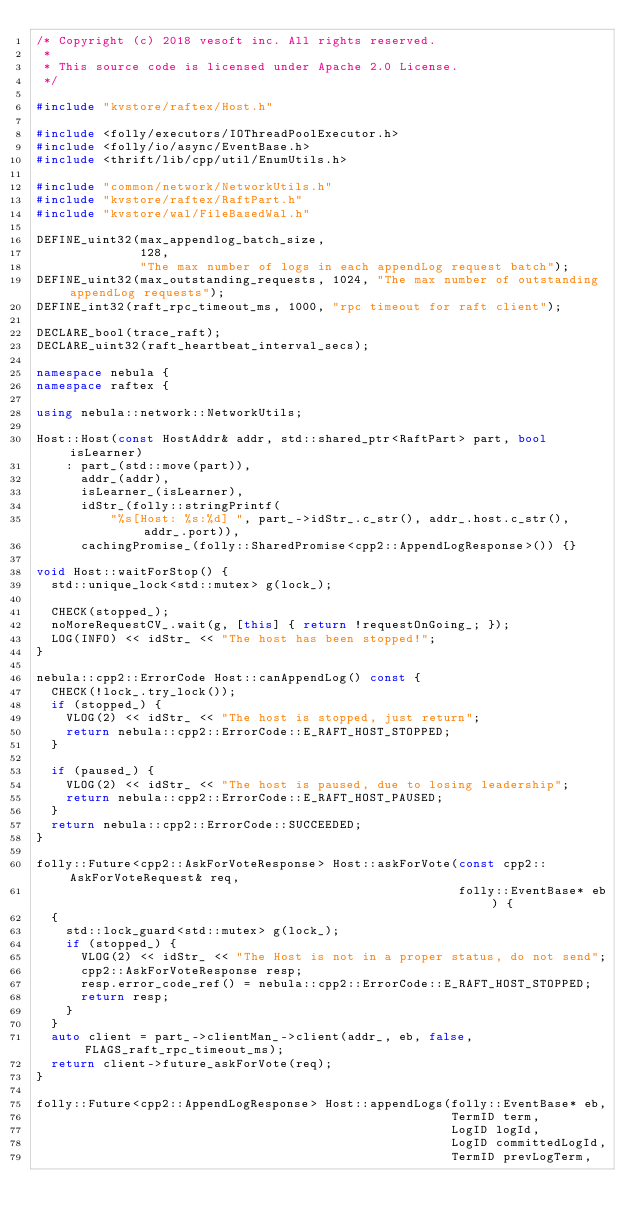Convert code to text. <code><loc_0><loc_0><loc_500><loc_500><_C++_>/* Copyright (c) 2018 vesoft inc. All rights reserved.
 *
 * This source code is licensed under Apache 2.0 License.
 */

#include "kvstore/raftex/Host.h"

#include <folly/executors/IOThreadPoolExecutor.h>
#include <folly/io/async/EventBase.h>
#include <thrift/lib/cpp/util/EnumUtils.h>

#include "common/network/NetworkUtils.h"
#include "kvstore/raftex/RaftPart.h"
#include "kvstore/wal/FileBasedWal.h"

DEFINE_uint32(max_appendlog_batch_size,
              128,
              "The max number of logs in each appendLog request batch");
DEFINE_uint32(max_outstanding_requests, 1024, "The max number of outstanding appendLog requests");
DEFINE_int32(raft_rpc_timeout_ms, 1000, "rpc timeout for raft client");

DECLARE_bool(trace_raft);
DECLARE_uint32(raft_heartbeat_interval_secs);

namespace nebula {
namespace raftex {

using nebula::network::NetworkUtils;

Host::Host(const HostAddr& addr, std::shared_ptr<RaftPart> part, bool isLearner)
    : part_(std::move(part)),
      addr_(addr),
      isLearner_(isLearner),
      idStr_(folly::stringPrintf(
          "%s[Host: %s:%d] ", part_->idStr_.c_str(), addr_.host.c_str(), addr_.port)),
      cachingPromise_(folly::SharedPromise<cpp2::AppendLogResponse>()) {}

void Host::waitForStop() {
  std::unique_lock<std::mutex> g(lock_);

  CHECK(stopped_);
  noMoreRequestCV_.wait(g, [this] { return !requestOnGoing_; });
  LOG(INFO) << idStr_ << "The host has been stopped!";
}

nebula::cpp2::ErrorCode Host::canAppendLog() const {
  CHECK(!lock_.try_lock());
  if (stopped_) {
    VLOG(2) << idStr_ << "The host is stopped, just return";
    return nebula::cpp2::ErrorCode::E_RAFT_HOST_STOPPED;
  }

  if (paused_) {
    VLOG(2) << idStr_ << "The host is paused, due to losing leadership";
    return nebula::cpp2::ErrorCode::E_RAFT_HOST_PAUSED;
  }
  return nebula::cpp2::ErrorCode::SUCCEEDED;
}

folly::Future<cpp2::AskForVoteResponse> Host::askForVote(const cpp2::AskForVoteRequest& req,
                                                         folly::EventBase* eb) {
  {
    std::lock_guard<std::mutex> g(lock_);
    if (stopped_) {
      VLOG(2) << idStr_ << "The Host is not in a proper status, do not send";
      cpp2::AskForVoteResponse resp;
      resp.error_code_ref() = nebula::cpp2::ErrorCode::E_RAFT_HOST_STOPPED;
      return resp;
    }
  }
  auto client = part_->clientMan_->client(addr_, eb, false, FLAGS_raft_rpc_timeout_ms);
  return client->future_askForVote(req);
}

folly::Future<cpp2::AppendLogResponse> Host::appendLogs(folly::EventBase* eb,
                                                        TermID term,
                                                        LogID logId,
                                                        LogID committedLogId,
                                                        TermID prevLogTerm,</code> 